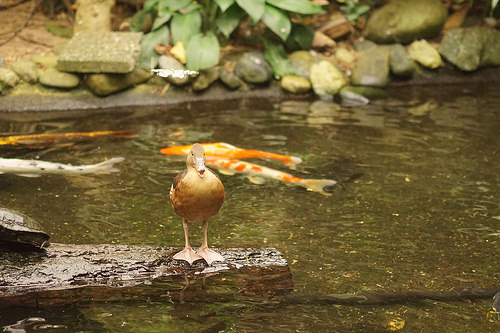<image>
Is the turtle on the water? No. The turtle is not positioned on the water. They may be near each other, but the turtle is not supported by or resting on top of the water. Where is the duck in relation to the fish? Is it under the fish? No. The duck is not positioned under the fish. The vertical relationship between these objects is different. 